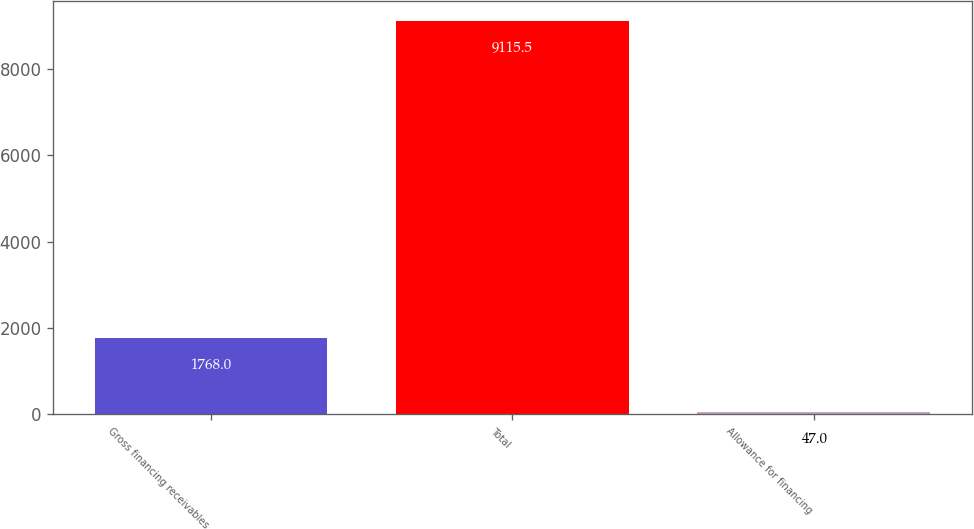Convert chart to OTSL. <chart><loc_0><loc_0><loc_500><loc_500><bar_chart><fcel>Gross financing receivables<fcel>Total<fcel>Allowance for financing<nl><fcel>1768<fcel>9115.5<fcel>47<nl></chart> 